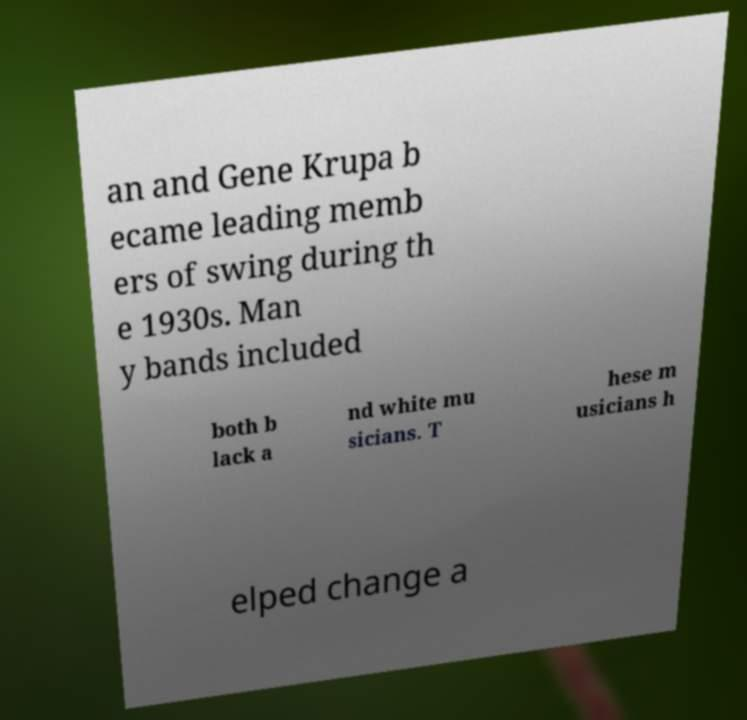Could you assist in decoding the text presented in this image and type it out clearly? an and Gene Krupa b ecame leading memb ers of swing during th e 1930s. Man y bands included both b lack a nd white mu sicians. T hese m usicians h elped change a 